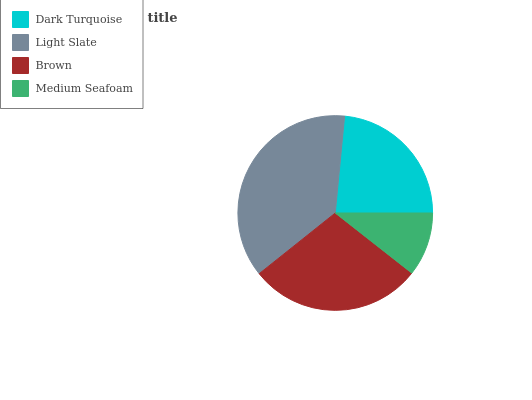Is Medium Seafoam the minimum?
Answer yes or no. Yes. Is Light Slate the maximum?
Answer yes or no. Yes. Is Brown the minimum?
Answer yes or no. No. Is Brown the maximum?
Answer yes or no. No. Is Light Slate greater than Brown?
Answer yes or no. Yes. Is Brown less than Light Slate?
Answer yes or no. Yes. Is Brown greater than Light Slate?
Answer yes or no. No. Is Light Slate less than Brown?
Answer yes or no. No. Is Brown the high median?
Answer yes or no. Yes. Is Dark Turquoise the low median?
Answer yes or no. Yes. Is Medium Seafoam the high median?
Answer yes or no. No. Is Brown the low median?
Answer yes or no. No. 